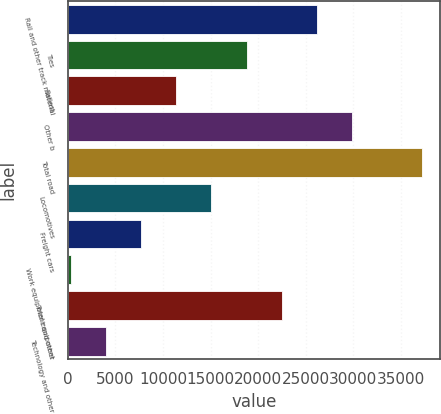<chart> <loc_0><loc_0><loc_500><loc_500><bar_chart><fcel>Rail and other track material<fcel>Ties<fcel>Ballast<fcel>Other b<fcel>Total road<fcel>Locomotives<fcel>Freight cars<fcel>Work equipment and other<fcel>Total equipment<fcel>Technology and other<nl><fcel>26179.1<fcel>18786.5<fcel>11393.9<fcel>29875.4<fcel>37268<fcel>15090.2<fcel>7697.6<fcel>305<fcel>22482.8<fcel>4001.3<nl></chart> 